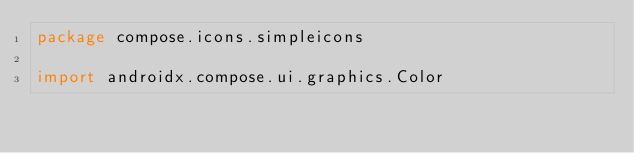Convert code to text. <code><loc_0><loc_0><loc_500><loc_500><_Kotlin_>package compose.icons.simpleicons

import androidx.compose.ui.graphics.Color</code> 